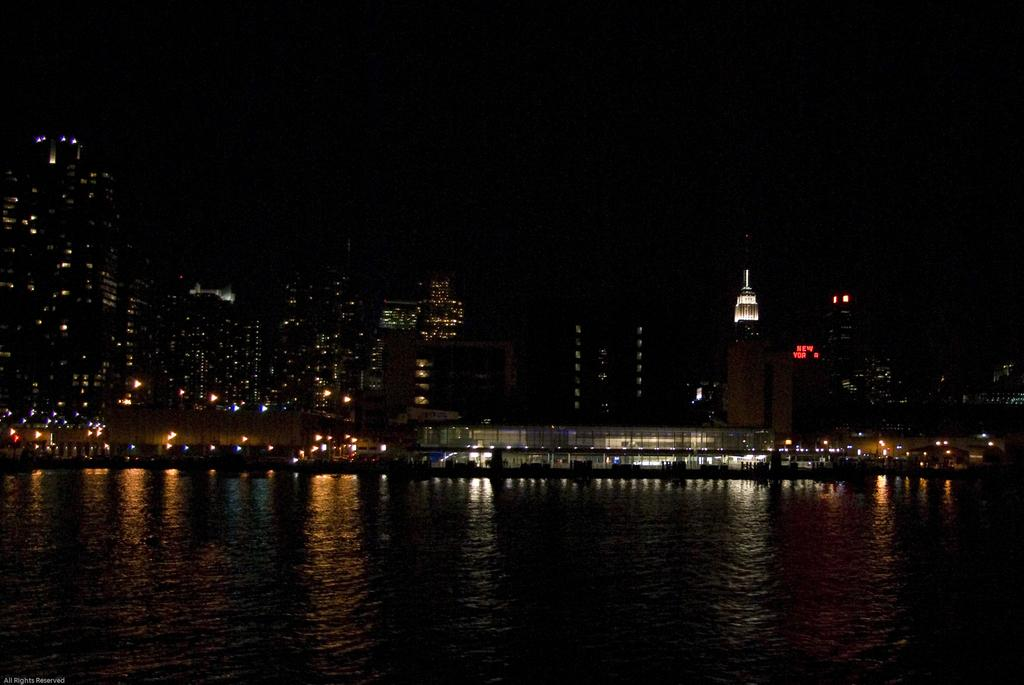What is visible in the image? Water is visible in the image. What can be seen in the background of the image? There are buildings and lights in the background of the image. How would you describe the lighting in the image? The top part of the image appears to be dark. How does the pollution affect the water in the image? There is no mention of pollution in the image, so we cannot determine its effect on the water. 